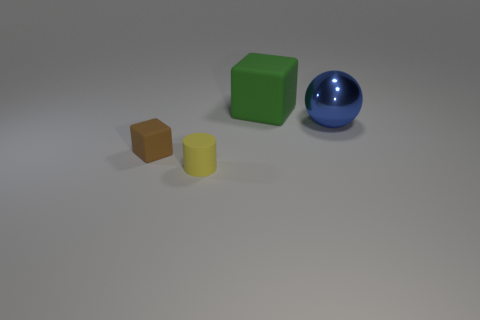What number of other objects are there of the same size as the yellow thing?
Keep it short and to the point. 1. There is a object that is both right of the yellow object and left of the blue sphere; what is its material?
Provide a short and direct response. Rubber. What is the shape of the thing that is to the right of the matte cube that is behind the big sphere?
Make the answer very short. Sphere. How many yellow objects are either small rubber things or small rubber cylinders?
Offer a terse response. 1. Are there any cubes in front of the big blue thing?
Provide a short and direct response. Yes. What is the size of the brown rubber thing?
Provide a short and direct response. Small. The green object that is the same shape as the tiny brown thing is what size?
Give a very brief answer. Large. How many blue objects are on the right side of the small matte thing that is behind the yellow cylinder?
Your answer should be compact. 1. Is the material of the cube that is on the left side of the big block the same as the thing that is behind the ball?
Offer a terse response. Yes. How many small brown objects have the same shape as the small yellow object?
Your response must be concise. 0. 